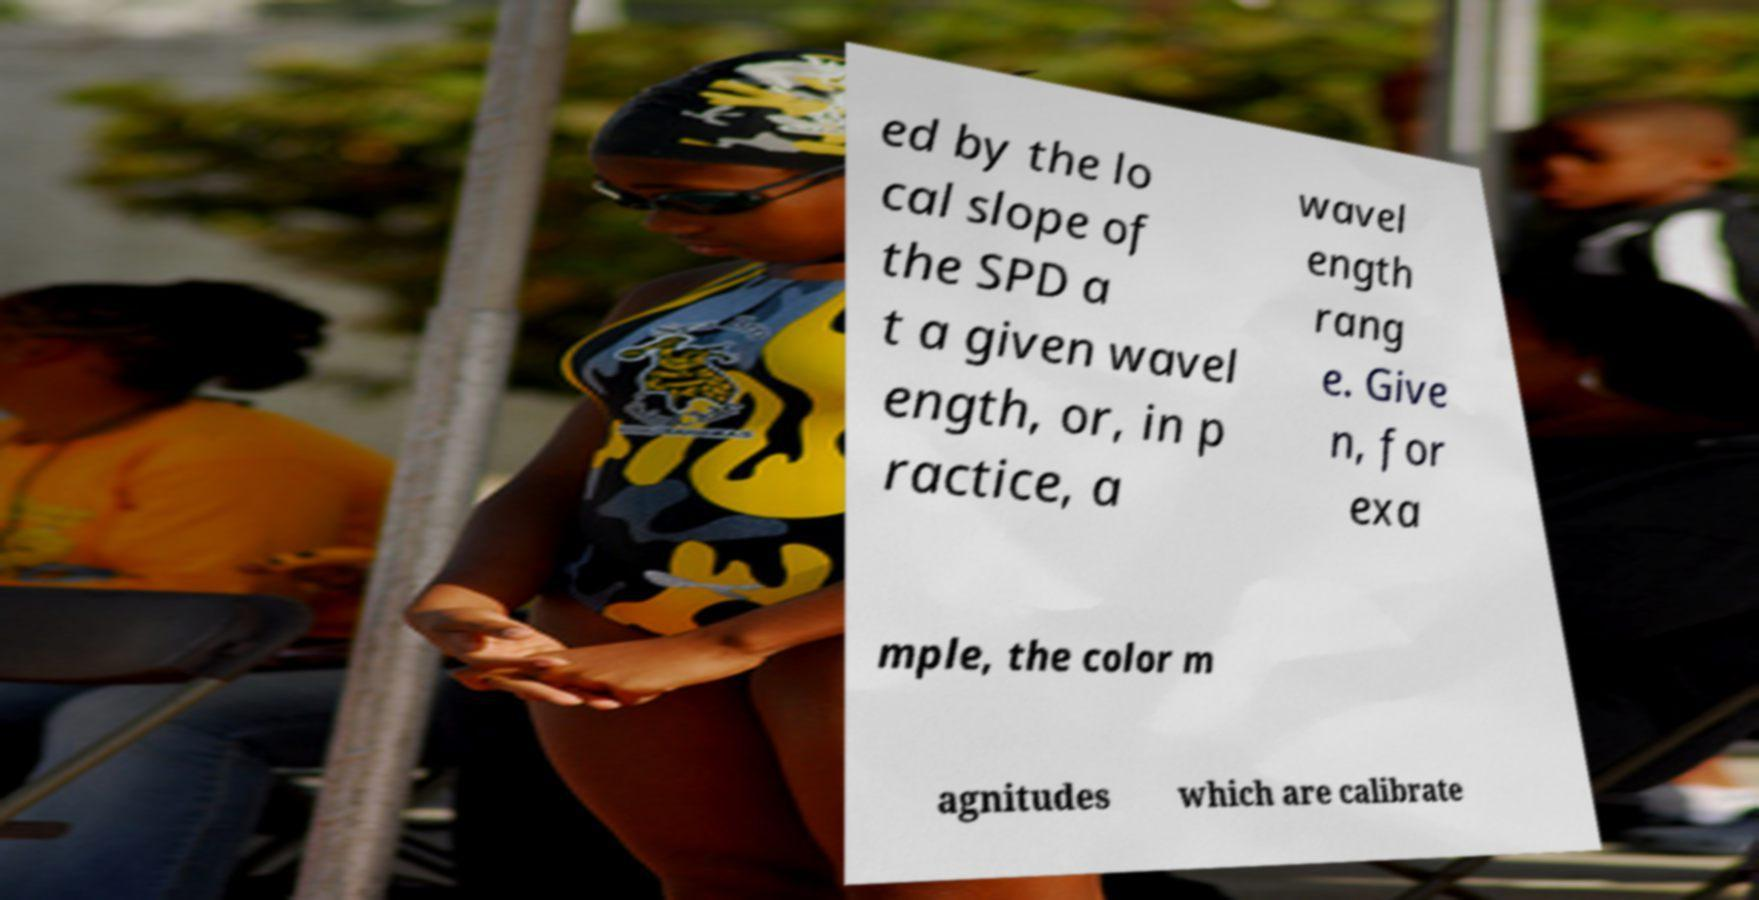Please identify and transcribe the text found in this image. ed by the lo cal slope of the SPD a t a given wavel ength, or, in p ractice, a wavel ength rang e. Give n, for exa mple, the color m agnitudes which are calibrate 